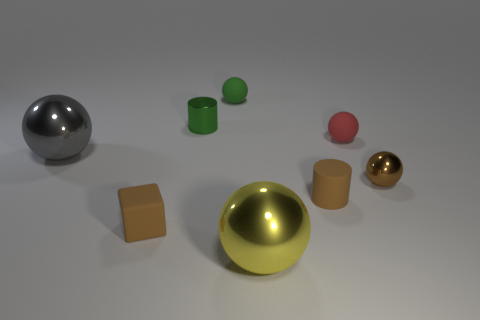Does the matte ball behind the green metal cylinder have the same color as the tiny metal object that is on the left side of the yellow ball?
Provide a succinct answer. Yes. How many other things are there of the same material as the green cylinder?
Provide a succinct answer. 3. Are there any large metallic objects?
Provide a short and direct response. Yes. Does the cylinder that is behind the big gray ball have the same material as the large gray object?
Your answer should be compact. Yes. There is a large gray thing that is the same shape as the large yellow shiny object; what is it made of?
Give a very brief answer. Metal. What material is the cylinder that is the same color as the matte cube?
Provide a succinct answer. Rubber. Are there fewer tiny brown metallic spheres than balls?
Offer a terse response. Yes. Is the color of the small metallic object right of the yellow object the same as the rubber block?
Make the answer very short. Yes. What color is the other tiny ball that is made of the same material as the small green ball?
Provide a succinct answer. Red. Do the gray metal thing and the block have the same size?
Give a very brief answer. No. 